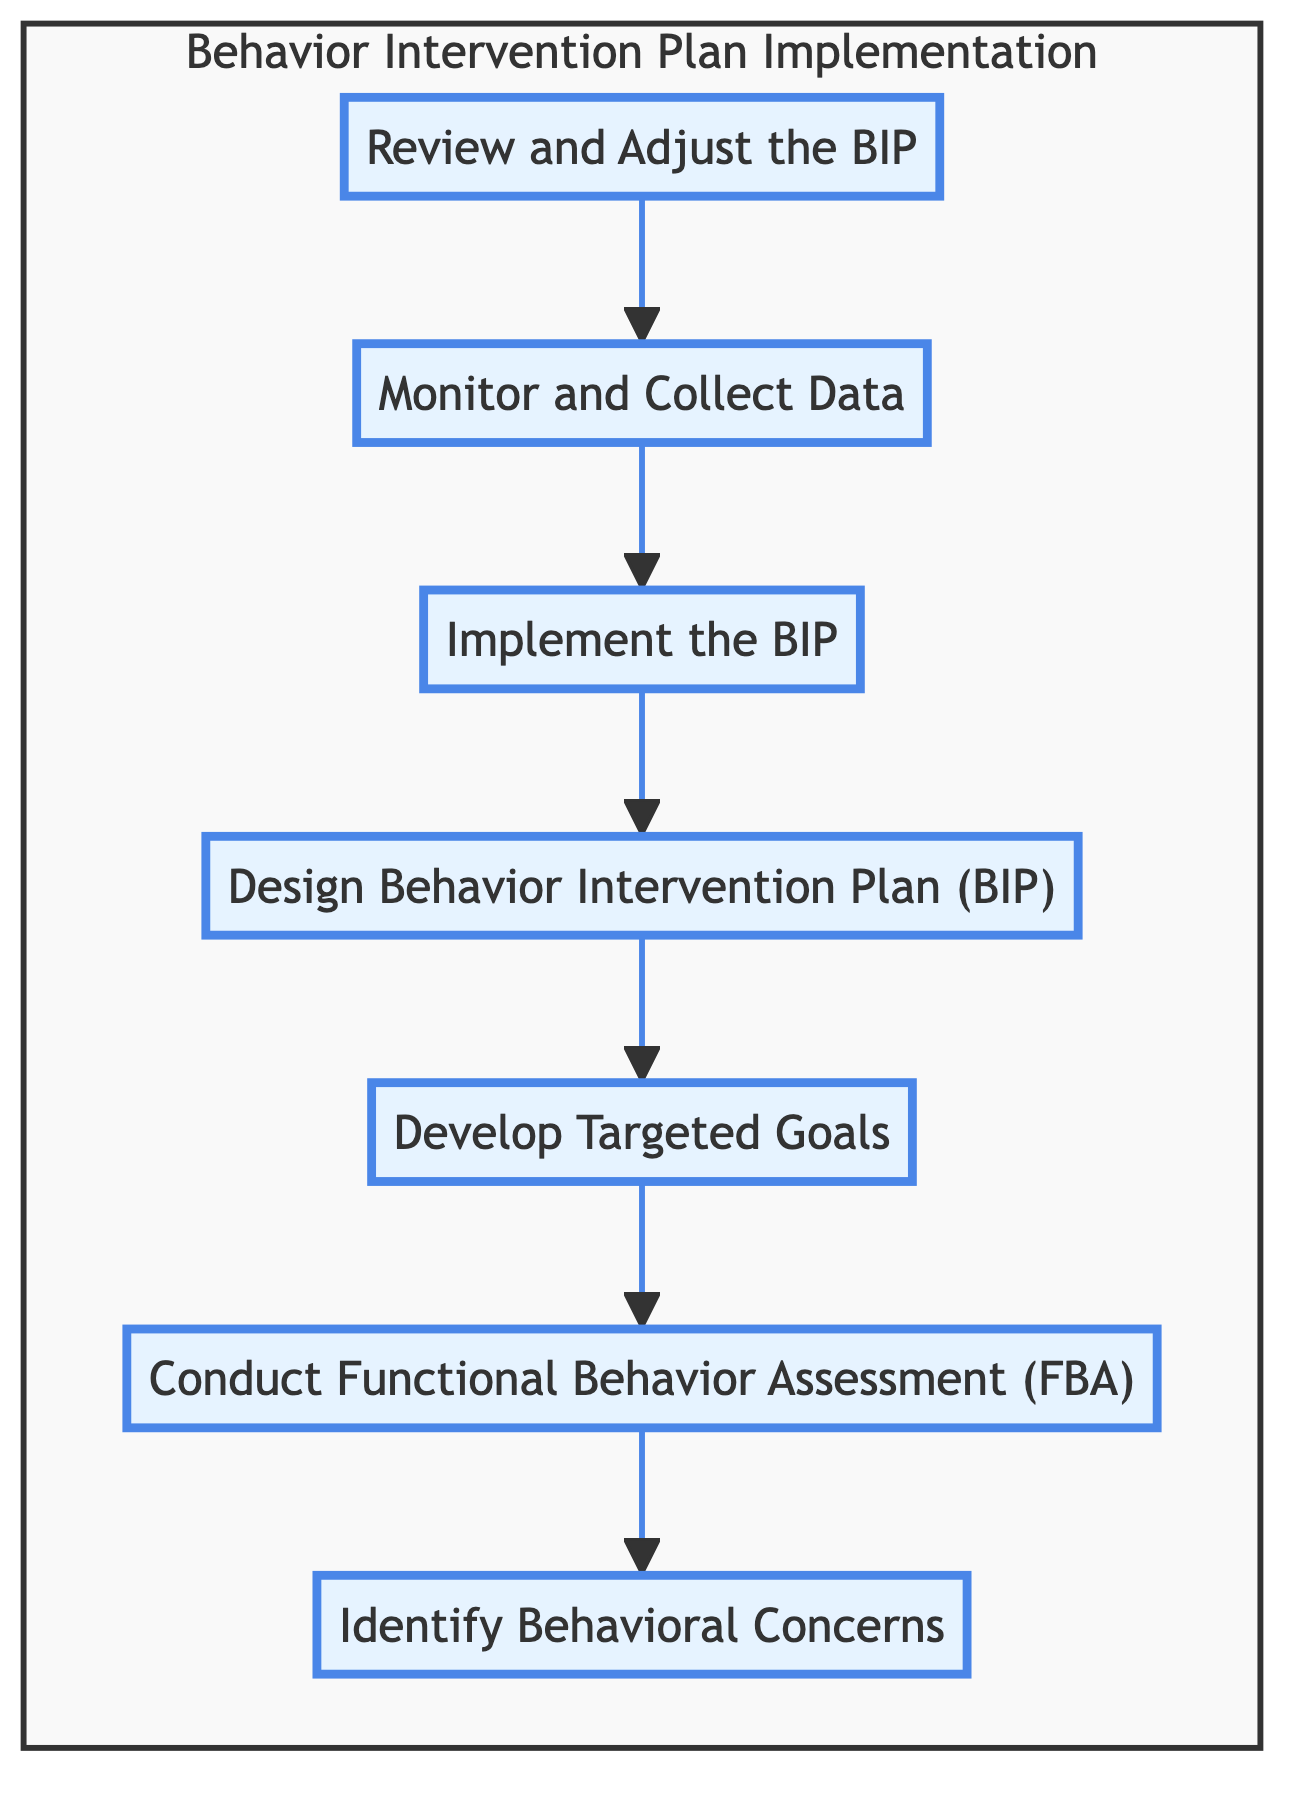What is the first step in the flowchart? The first step in the flowchart is identified by the bottom node that leads to others, which is "Identify Behavioral Concerns." This node does not have any incoming connections, indicating it is the starting point of the process.
Answer: Identify Behavioral Concerns How many steps are in the flowchart? By counting all the nodes listed in the flowchart, we see there are a total of seven steps from "Identify Behavioral Concerns" to "Review and Adjust the BIP."
Answer: 7 What step comes immediately before "Review and Adjust the BIP"? To find this, we trace the arrows leading into "Review and Adjust the BIP" and see that the arrow comes from "Monitor and Collect Data," making it the direct preceding step.
Answer: Monitor and Collect Data What is the final step in the behavior intervention plan process? In the flowchart, the final step is represented by the last node that does not point to any other, which is "Review and Adjust the BIP." This indicates the conclusion of the process after monitoring and implementing.
Answer: Review and Adjust the BIP Which step focuses on creating a structured plan? By examining the nodes, "Design Behavior Intervention Plan (BIP)" specifically pertains to the creation of a structured plan for interventions, as indicated by its description in the diagram.
Answer: Design Behavior Intervention Plan (BIP) What step follows after "Implement the BIP"? To determine the next step, we look at the arrows stemming from "Implement the BIP" and see that the flow continues to "Monitor and Collect Data," which is the subsequent step in the process.
Answer: Monitor and Collect Data Which two steps are directly related to data collection and analysis? Analyzing the flowchart, "Conduct Functional Behavior Assessment (FBA)" and "Monitor and Collect Data" are both concerned with the aspect of gathering and analyzing data to understand and evaluate behavior interventions.
Answer: Conduct Functional Behavior Assessment (FBA) and Monitor and Collect Data What describes the purpose of the "Develop Targeted Goals" step? The purpose can be identified by looking at its description in the diagram, which clearly states the aim is to establish goals that address behaviors and promote positive alternatives.
Answer: Establish clear and measurable goals 